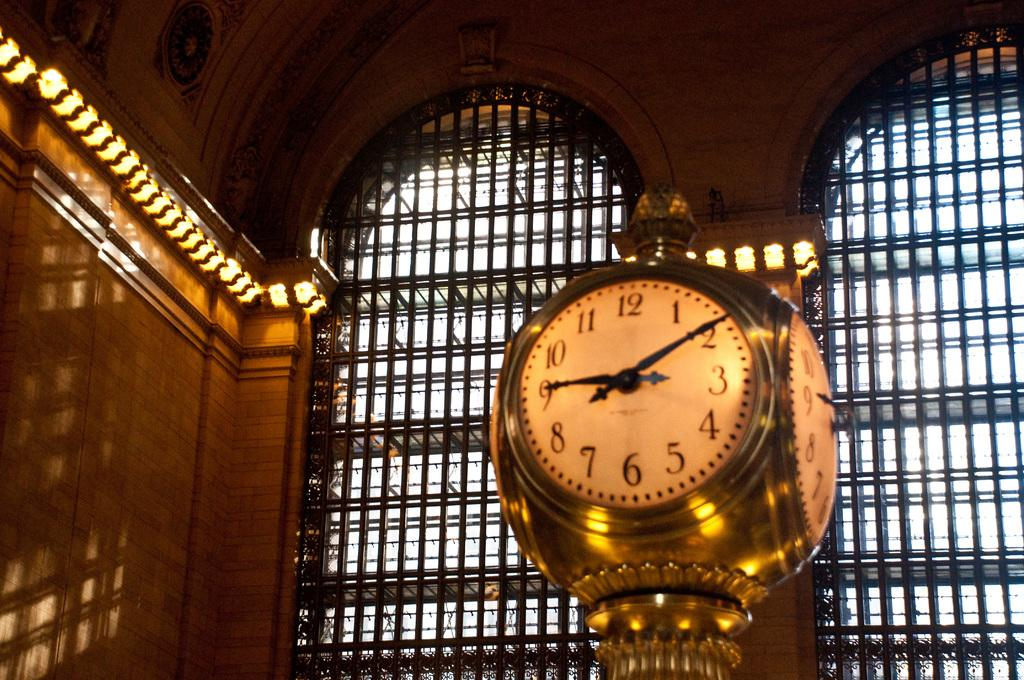<image>
Present a compact description of the photo's key features. A clock in a dark room shows the time is 9;09. 